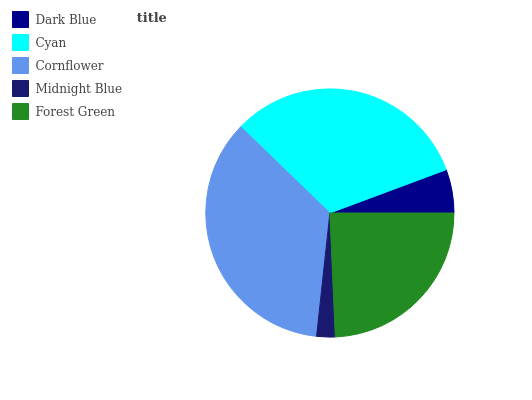Is Midnight Blue the minimum?
Answer yes or no. Yes. Is Cornflower the maximum?
Answer yes or no. Yes. Is Cyan the minimum?
Answer yes or no. No. Is Cyan the maximum?
Answer yes or no. No. Is Cyan greater than Dark Blue?
Answer yes or no. Yes. Is Dark Blue less than Cyan?
Answer yes or no. Yes. Is Dark Blue greater than Cyan?
Answer yes or no. No. Is Cyan less than Dark Blue?
Answer yes or no. No. Is Forest Green the high median?
Answer yes or no. Yes. Is Forest Green the low median?
Answer yes or no. Yes. Is Cornflower the high median?
Answer yes or no. No. Is Midnight Blue the low median?
Answer yes or no. No. 